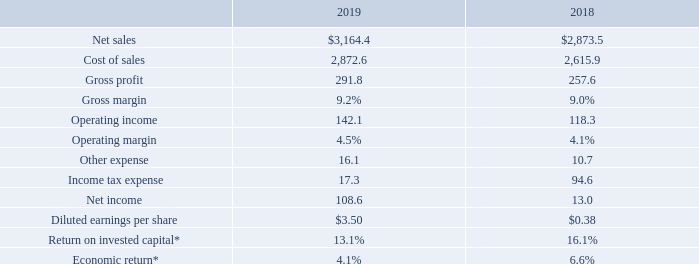ITEM 7. MANAGEMENT’S DISCUSSION AND ANALYSIS OF FINANCIAL CONDITION AND RESULTS OF OPERATIONS
RESULTS OF OPERATIONS
Consolidated Performance Summary. The following table presents selected consolidated financial data for the indicated fiscal years (dollars in millions, except per share data):
*Non-GAAP metric; refer to "Return on Invested Capital ("ROIC") and Economic Return" below for more information and Exhibit 99.1 for a reconciliation.
Net sales. Fiscal 2019 net sales increased $290.9 million, or 10.1%, as compared to fiscal 2018.
Net sales are analyzed by management by geographic segment, which reflects the Company's reportable segments, and by market sector. Management measures operational performance and allocates resources on a geographic segment basis. The Company’s global business development strategy is based on our targeted market sectors.
What was the increase in net sales between 2018 and 2019?
Answer scale should be: million. 290.9. How was net sales analyzed? By management by geographic segment, which reflects the company's reportable segments, and by market sector. What was the cost of sales in 2018?
Answer scale should be: thousand. 2,615.9. How many years did the operating margin exceed 4%? 2019##2018
Answer: 2. What was the change in the gross profit between 2018 and 2019?
Answer scale should be: million. 291.8-257.6
Answer: 34.2. What was the percentage change in Income tax expense between 2018 and 2019?
Answer scale should be: percent. (17.3-94.6)/94.6
Answer: -81.71. 